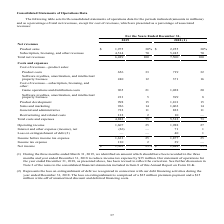According to Activision Blizzard's financial document, What does the loss on extinguishment comprise of? a $25 million premium payment and a $15 million write-off of unamortized discount and deferred financing costs.. The document states: ", 2018. The loss on extinguishment is comprised of a $25 million premium payment and a $15 million write-off of unamortized discount and deferred fina..." Also, What was net income in 2019? According to the financial document, $1,503 (in millions). The relevant text states: "Net income $ 1,503 23% $ 1,848 25%..." Also, What was net income in 2018? According to the financial document, $1,848 (in millions). The relevant text states: "Net income $ 1,503 23% $ 1,848 25%..." Also, can you calculate: What is the percentage change in product costs between 2018 and 2019? To answer this question, I need to perform calculations using the financial data. The calculation is: (656-719)/719, which equals -8.76 (percentage). This is based on the information: "Product costs 656 33 719 32 Product costs 656 33 719 32..." The key data points involved are: 656, 719. Also, can you calculate: What is the percentage change in operating income between 2018 and 2019? To answer this question, I need to perform calculations using the financial data. The calculation is: (1,607-1,988)/1,988, which equals -19.16 (percentage). This is based on the information: "Operating income 1,607 25 1,988 27 Operating income 1,607 25 1,988 27..." The key data points involved are: 1,607, 1,988. Also, can you calculate: What is the difference in game operations and distribution costs between 2018 and 2019? Based on the calculation: (1,028-965), the result is 63 (in millions). This is based on the information: "Game operations and distribution costs 965 21 1,028 20 Game operations and distribution costs 965 21 1,028 20..." The key data points involved are: 1,028, 965. 